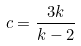Convert formula to latex. <formula><loc_0><loc_0><loc_500><loc_500>c = \frac { 3 k } { k - 2 }</formula> 